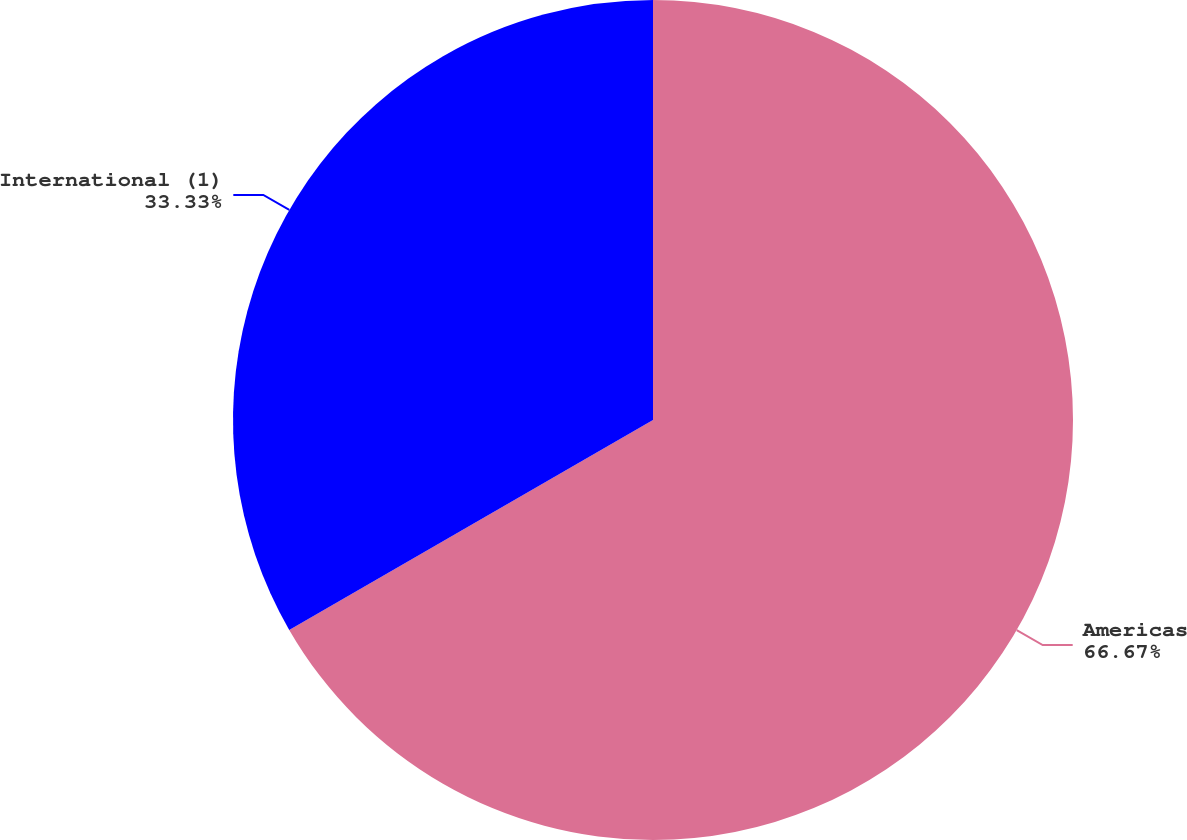Convert chart to OTSL. <chart><loc_0><loc_0><loc_500><loc_500><pie_chart><fcel>Americas<fcel>International (1)<nl><fcel>66.67%<fcel>33.33%<nl></chart> 